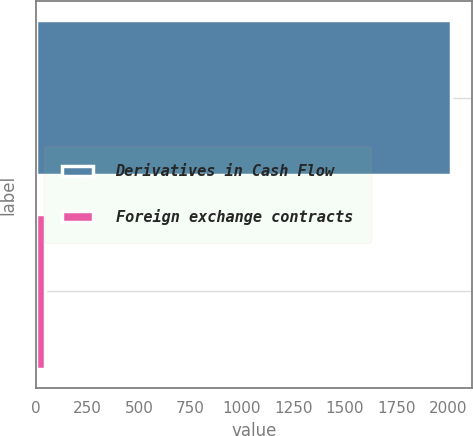<chart> <loc_0><loc_0><loc_500><loc_500><bar_chart><fcel>Derivatives in Cash Flow<fcel>Foreign exchange contracts<nl><fcel>2015<fcel>44<nl></chart> 